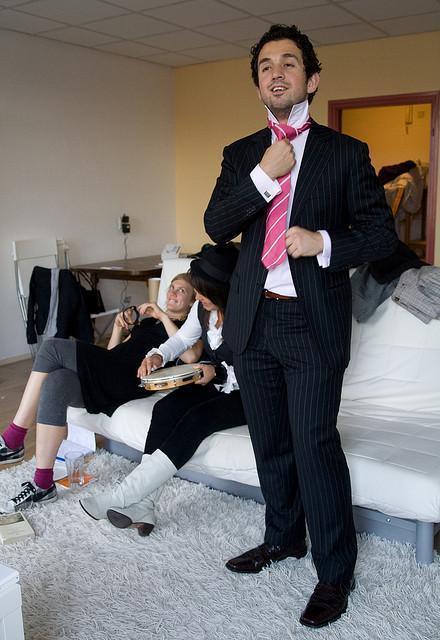How many people are sitting?
Give a very brief answer. 2. How many people can you see?
Give a very brief answer. 3. How many dark umbrellas are there?
Give a very brief answer. 0. 